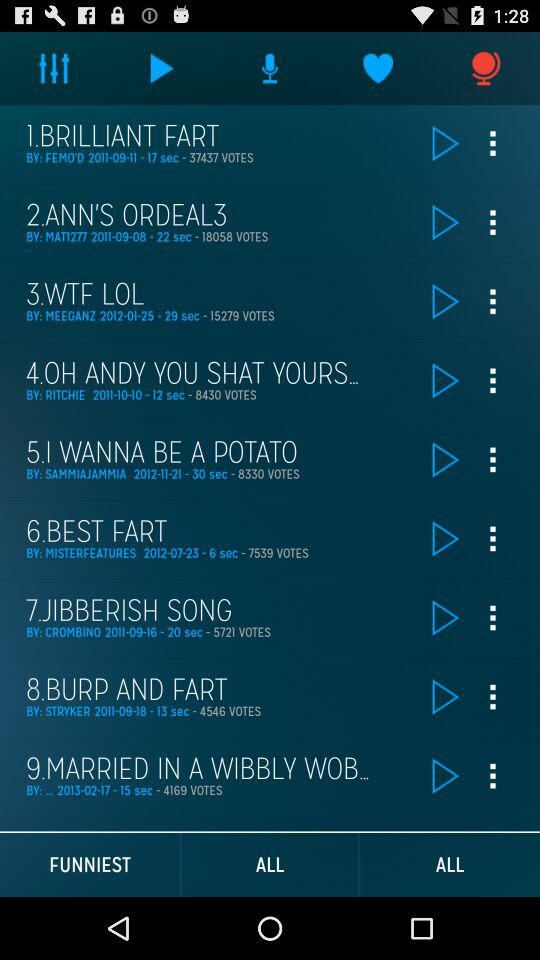How many people voted for the burp and fart song? The number of people who voted is 4546. 